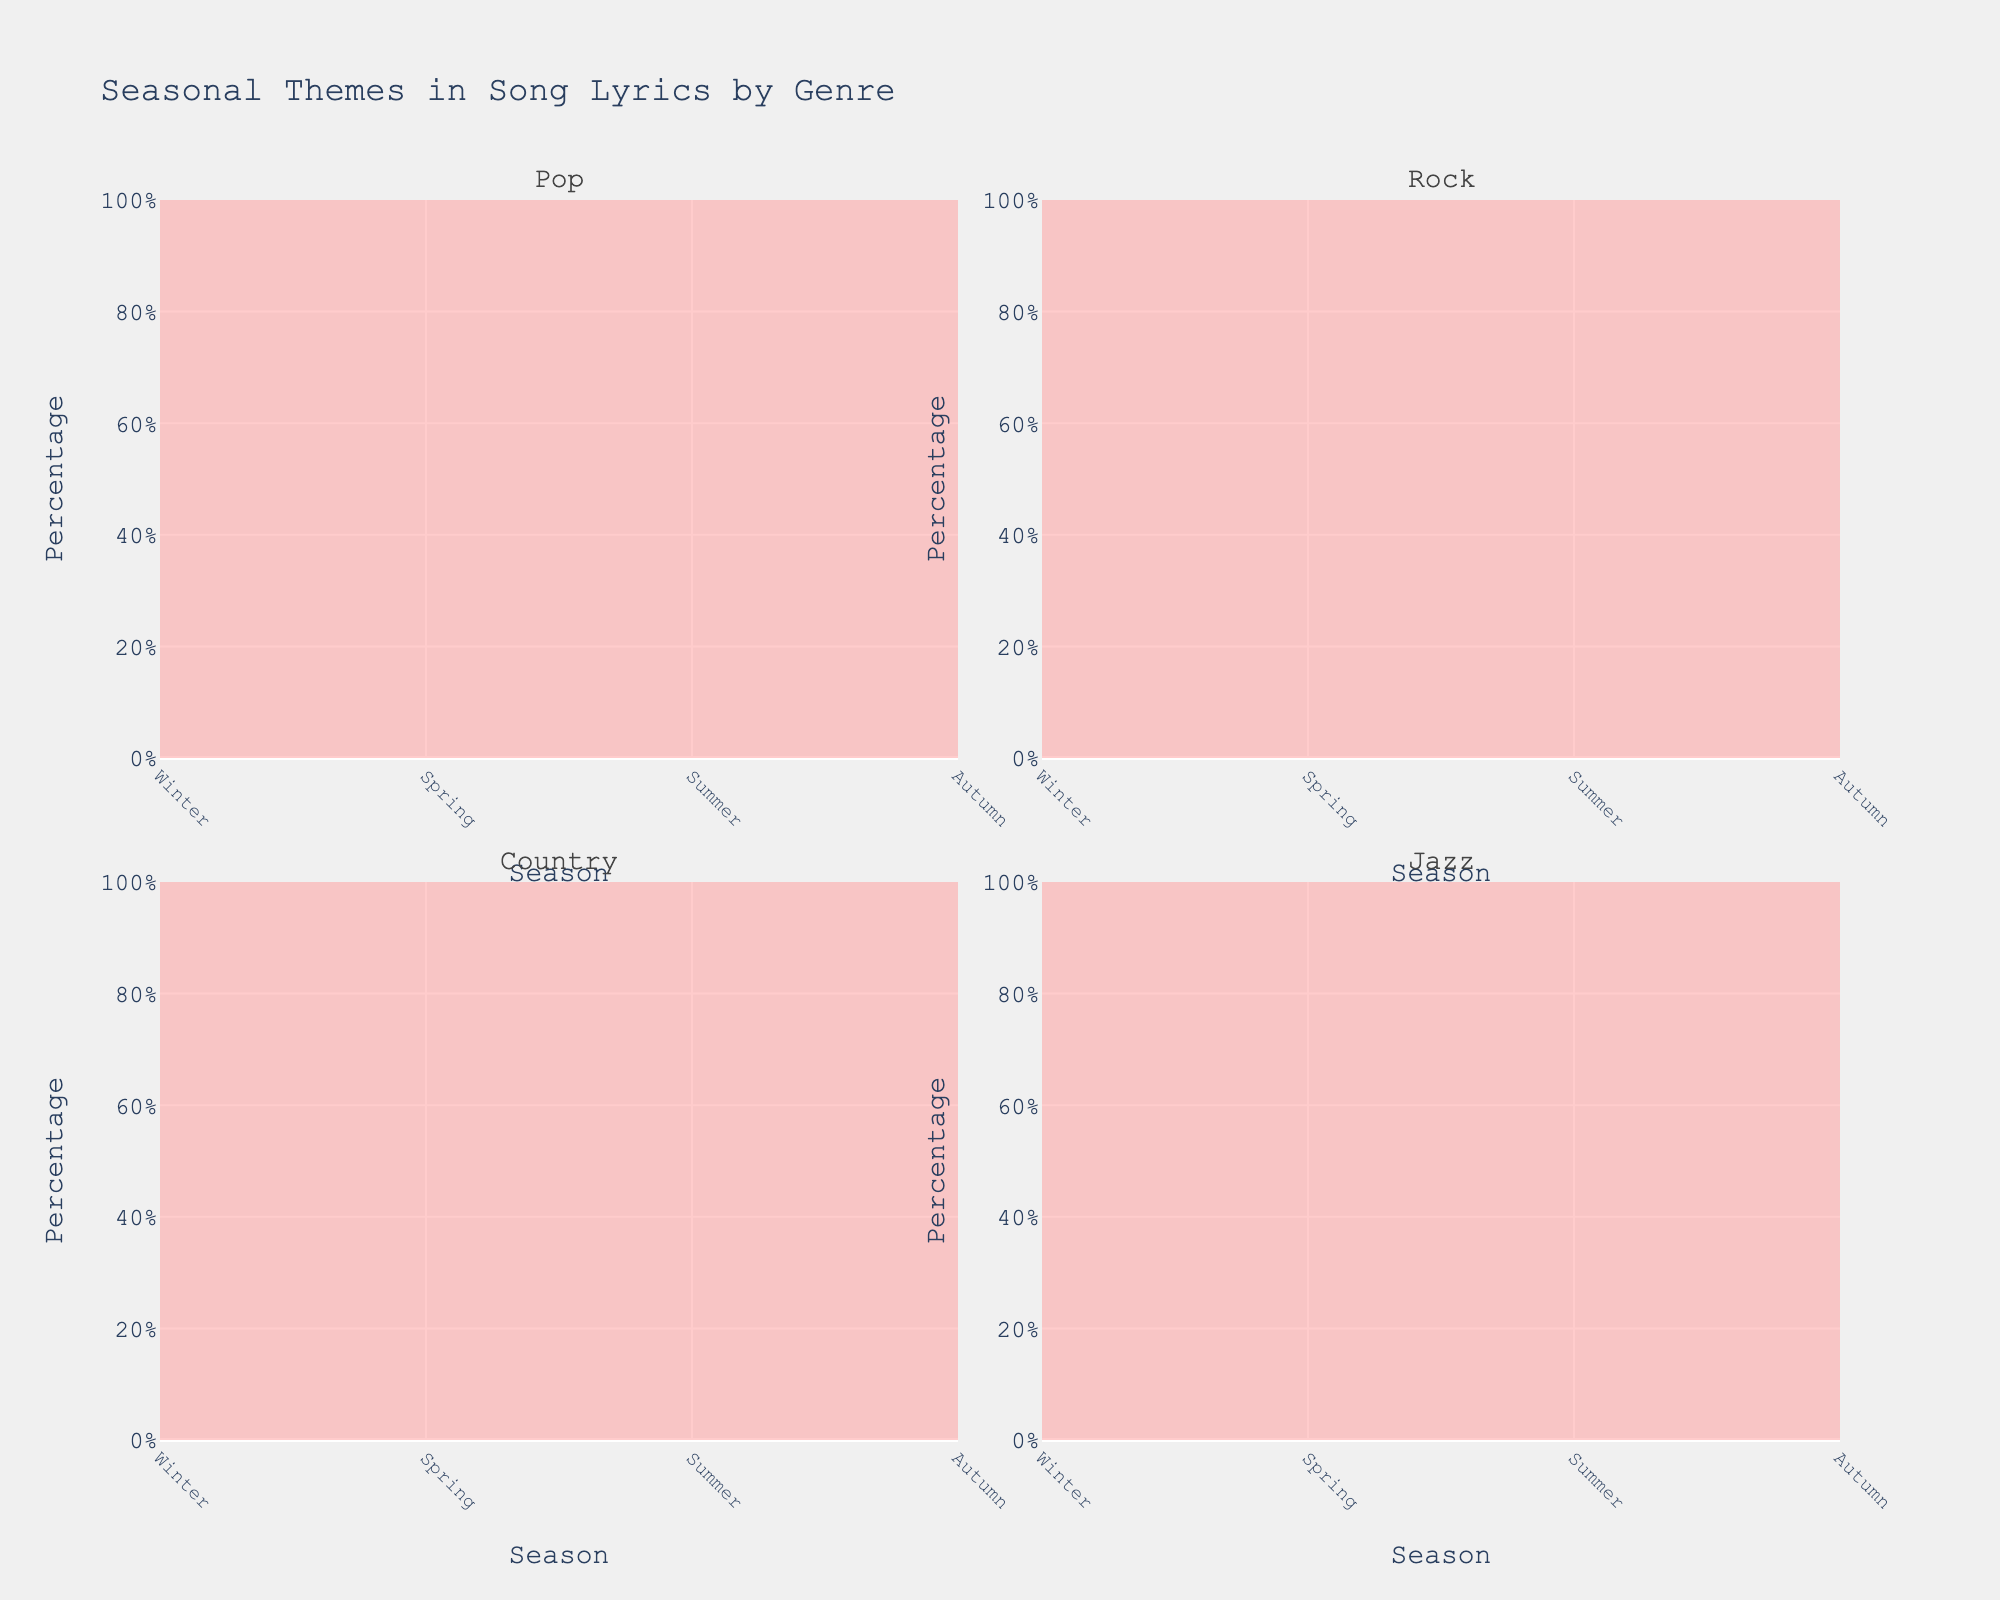How many genres are displayed in the figure? Look at the subplot titles; there are four rectangles, each for a different genre. The titles indicate "Pop", "Rock", "Country", and "Jazz".
Answer: 4 What is the theme with the highest percentage in Pop songs during the Summer? Check the Pop subplot and look at the Summer season. The highest line segment is colored differently for each theme. You can see that "Joy" (yellow-orange) has the largest segment.
Answer: Joy Which season shows the most significant change in "Nature" themes across all genres? Look at each genre's subplot individually and observe the height of the "Nature" theme (green). Notice which season has the most noticeable height change. "Nature" increases significantly in Spring for all genres.
Answer: Spring Does "Love" have a higher percentage in Summer or Autumn for Country music? Compare the height of the pink segment labeled "Love" in Country for both Summer and Autumn. In Summer, the height is at 35, whereas in Autumn, it is at 30.
Answer: Summer What is the difference in percentage representation of "Loss" in Winter between Pop and Rock? Compare the height of the blue segment named "Loss" for Pop and Rock in Winter. For Pop, it is at 40, and for Rock, it is at 45. The difference is 45 - 40.
Answer: 5 Across all genres, which theme shows the most consistency throughout the year in their representation percentages? Observe each subplot's themes across the seasons. Notice that "Joy" (yellow-orange) has a similar percentage range across most seasons and genres.
Answer: Joy In which season does "Jazz" music have the highest representation of "Love"? Look at the Jazz subplot and identify the season where the pink segment called "Love" is the tallest. The highest is during Spring with 40.
Answer: Spring Which two themes have the closest percentage representation in Autumn for Rock music? Check the Rock subplot in Autumn and observe the height of each theme. "Love" (pink) at 20 and "Nature" (green) at 10. The closest percentages are "Nature" and "Joy" both at 35% and 35%.
Answer: Nature and Joy What's the trend for "Loss" in Rock songs from Winter to Autumn? Does it increase, decrease, or remain the same? Observe the Rock subplot and follow the blue segment labeled “Loss” across Winter, Spring, Summer, and Autumn. Notice that "Loss" peaks in Winter at 45, then decreases gradually through Spring at 20, Summer at 15, before increasing again in Autumn at 35. Overall, it first decreases then partially increases.
Answer: Decrease then Increase 